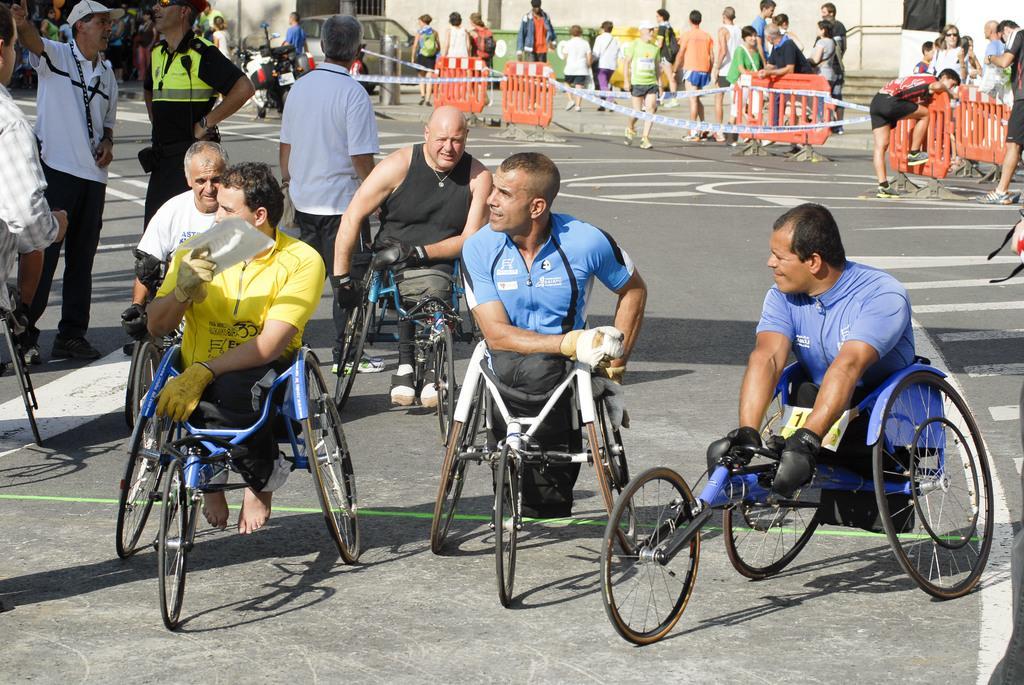Can you describe this image briefly? In this image I can see people where few are sitting on wheelchair cycles and rest all are standing. I can also see white lines on road and in background I can see few vehicles and few orange colour things. I can also see shadows over here. 